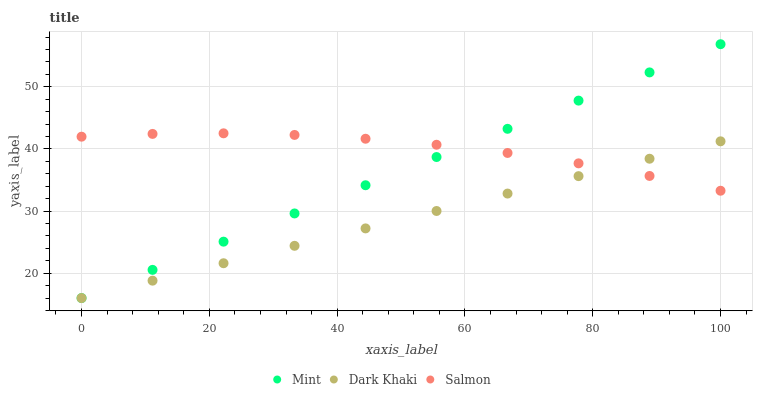Does Dark Khaki have the minimum area under the curve?
Answer yes or no. Yes. Does Salmon have the maximum area under the curve?
Answer yes or no. Yes. Does Mint have the minimum area under the curve?
Answer yes or no. No. Does Mint have the maximum area under the curve?
Answer yes or no. No. Is Mint the smoothest?
Answer yes or no. Yes. Is Salmon the roughest?
Answer yes or no. Yes. Is Salmon the smoothest?
Answer yes or no. No. Is Mint the roughest?
Answer yes or no. No. Does Dark Khaki have the lowest value?
Answer yes or no. Yes. Does Salmon have the lowest value?
Answer yes or no. No. Does Mint have the highest value?
Answer yes or no. Yes. Does Salmon have the highest value?
Answer yes or no. No. Does Dark Khaki intersect Salmon?
Answer yes or no. Yes. Is Dark Khaki less than Salmon?
Answer yes or no. No. Is Dark Khaki greater than Salmon?
Answer yes or no. No. 